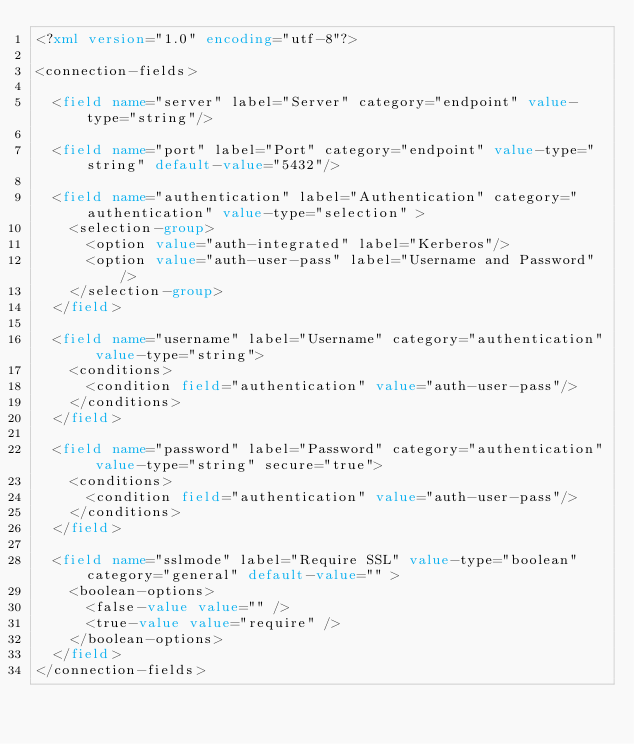Convert code to text. <code><loc_0><loc_0><loc_500><loc_500><_XML_><?xml version="1.0" encoding="utf-8"?>

<connection-fields>

  <field name="server" label="Server" category="endpoint" value-type="string"/>

  <field name="port" label="Port" category="endpoint" value-type="string" default-value="5432"/>

  <field name="authentication" label="Authentication" category="authentication" value-type="selection" >
    <selection-group>
      <option value="auth-integrated" label="Kerberos"/>
      <option value="auth-user-pass" label="Username and Password"/>
    </selection-group>
  </field>

  <field name="username" label="Username" category="authentication" value-type="string">
    <conditions>
      <condition field="authentication" value="auth-user-pass"/>
    </conditions>
  </field>

  <field name="password" label="Password" category="authentication" value-type="string" secure="true">
    <conditions>
      <condition field="authentication" value="auth-user-pass"/>
    </conditions>
  </field>
  
  <field name="sslmode" label="Require SSL" value-type="boolean" category="general" default-value="" >
    <boolean-options>
      <false-value value="" />
      <true-value value="require" />
    </boolean-options>
  </field>
</connection-fields>
</code> 